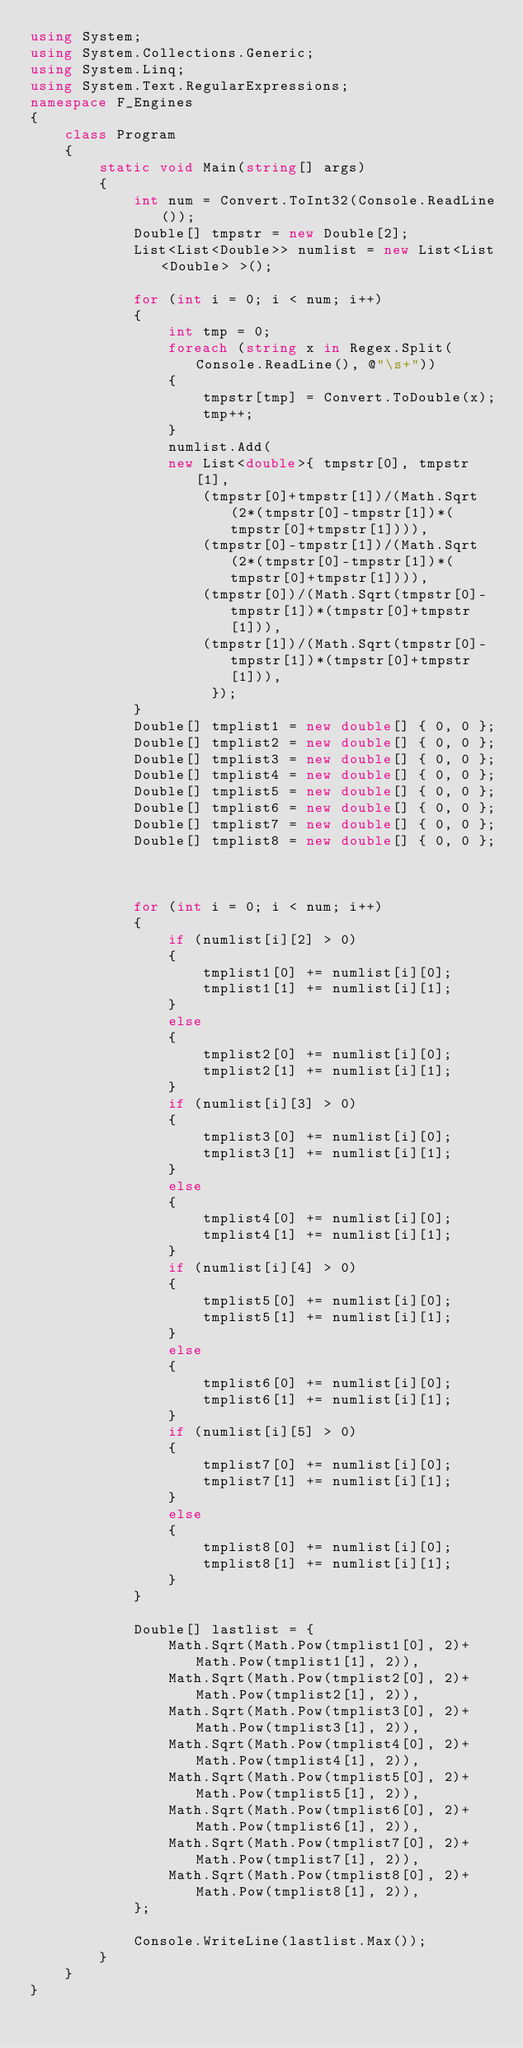<code> <loc_0><loc_0><loc_500><loc_500><_C#_>using System;
using System.Collections.Generic;
using System.Linq;
using System.Text.RegularExpressions;
namespace F_Engines
{
    class Program
    {
        static void Main(string[] args)
        {
            int num = Convert.ToInt32(Console.ReadLine());
            Double[] tmpstr = new Double[2];
            List<List<Double>> numlist = new List<List<Double> >();

            for (int i = 0; i < num; i++)
            {
                int tmp = 0;
                foreach (string x in Regex.Split(Console.ReadLine(), @"\s+"))
                {
                    tmpstr[tmp] = Convert.ToDouble(x);
                    tmp++;
                }
                numlist.Add(
                new List<double>{ tmpstr[0], tmpstr[1],
                    (tmpstr[0]+tmpstr[1])/(Math.Sqrt(2*(tmpstr[0]-tmpstr[1])*(tmpstr[0]+tmpstr[1]))),
                    (tmpstr[0]-tmpstr[1])/(Math.Sqrt(2*(tmpstr[0]-tmpstr[1])*(tmpstr[0]+tmpstr[1]))),
                    (tmpstr[0])/(Math.Sqrt(tmpstr[0]-tmpstr[1])*(tmpstr[0]+tmpstr[1])),
                    (tmpstr[1])/(Math.Sqrt(tmpstr[0]-tmpstr[1])*(tmpstr[0]+tmpstr[1])),
                     });
            }
            Double[] tmplist1 = new double[] { 0, 0 };
            Double[] tmplist2 = new double[] { 0, 0 };
            Double[] tmplist3 = new double[] { 0, 0 };
            Double[] tmplist4 = new double[] { 0, 0 };
            Double[] tmplist5 = new double[] { 0, 0 };
            Double[] tmplist6 = new double[] { 0, 0 };
            Double[] tmplist7 = new double[] { 0, 0 };
            Double[] tmplist8 = new double[] { 0, 0 };



            for (int i = 0; i < num; i++)
            {
                if (numlist[i][2] > 0)
                {
                    tmplist1[0] += numlist[i][0];
                    tmplist1[1] += numlist[i][1];
                }
                else
                {
                    tmplist2[0] += numlist[i][0];
                    tmplist2[1] += numlist[i][1];
                }
                if (numlist[i][3] > 0)
                {
                    tmplist3[0] += numlist[i][0];
                    tmplist3[1] += numlist[i][1];
                }
                else
                {
                    tmplist4[0] += numlist[i][0];
                    tmplist4[1] += numlist[i][1];
                }
                if (numlist[i][4] > 0)
                {
                    tmplist5[0] += numlist[i][0];
                    tmplist5[1] += numlist[i][1];
                }
                else
                {
                    tmplist6[0] += numlist[i][0];
                    tmplist6[1] += numlist[i][1];
                }
                if (numlist[i][5] > 0)
                {
                    tmplist7[0] += numlist[i][0];
                    tmplist7[1] += numlist[i][1];
                }
                else
                {
                    tmplist8[0] += numlist[i][0];
                    tmplist8[1] += numlist[i][1];
                }
            }

            Double[] lastlist = {
                Math.Sqrt(Math.Pow(tmplist1[0], 2)+ Math.Pow(tmplist1[1], 2)),
                Math.Sqrt(Math.Pow(tmplist2[0], 2)+ Math.Pow(tmplist2[1], 2)),
                Math.Sqrt(Math.Pow(tmplist3[0], 2)+ Math.Pow(tmplist3[1], 2)),
                Math.Sqrt(Math.Pow(tmplist4[0], 2)+ Math.Pow(tmplist4[1], 2)),
                Math.Sqrt(Math.Pow(tmplist5[0], 2)+ Math.Pow(tmplist5[1], 2)),
                Math.Sqrt(Math.Pow(tmplist6[0], 2)+ Math.Pow(tmplist6[1], 2)),
                Math.Sqrt(Math.Pow(tmplist7[0], 2)+ Math.Pow(tmplist7[1], 2)),
                Math.Sqrt(Math.Pow(tmplist8[0], 2)+ Math.Pow(tmplist8[1], 2)),
            };

            Console.WriteLine(lastlist.Max());
        }
    }
}
</code> 